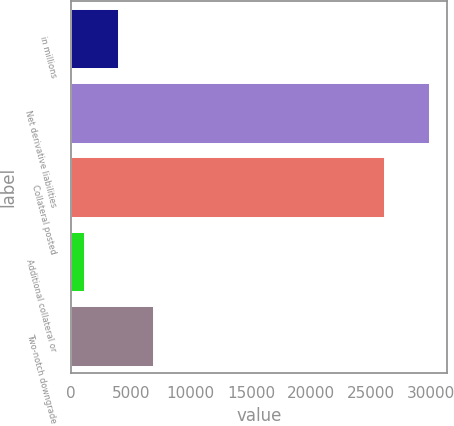Convert chart. <chart><loc_0><loc_0><loc_500><loc_500><bar_chart><fcel>in millions<fcel>Net derivative liabilities<fcel>Collateral posted<fcel>Additional collateral or<fcel>Two-notch downgrade<nl><fcel>3938.5<fcel>29836<fcel>26075<fcel>1061<fcel>6816<nl></chart> 